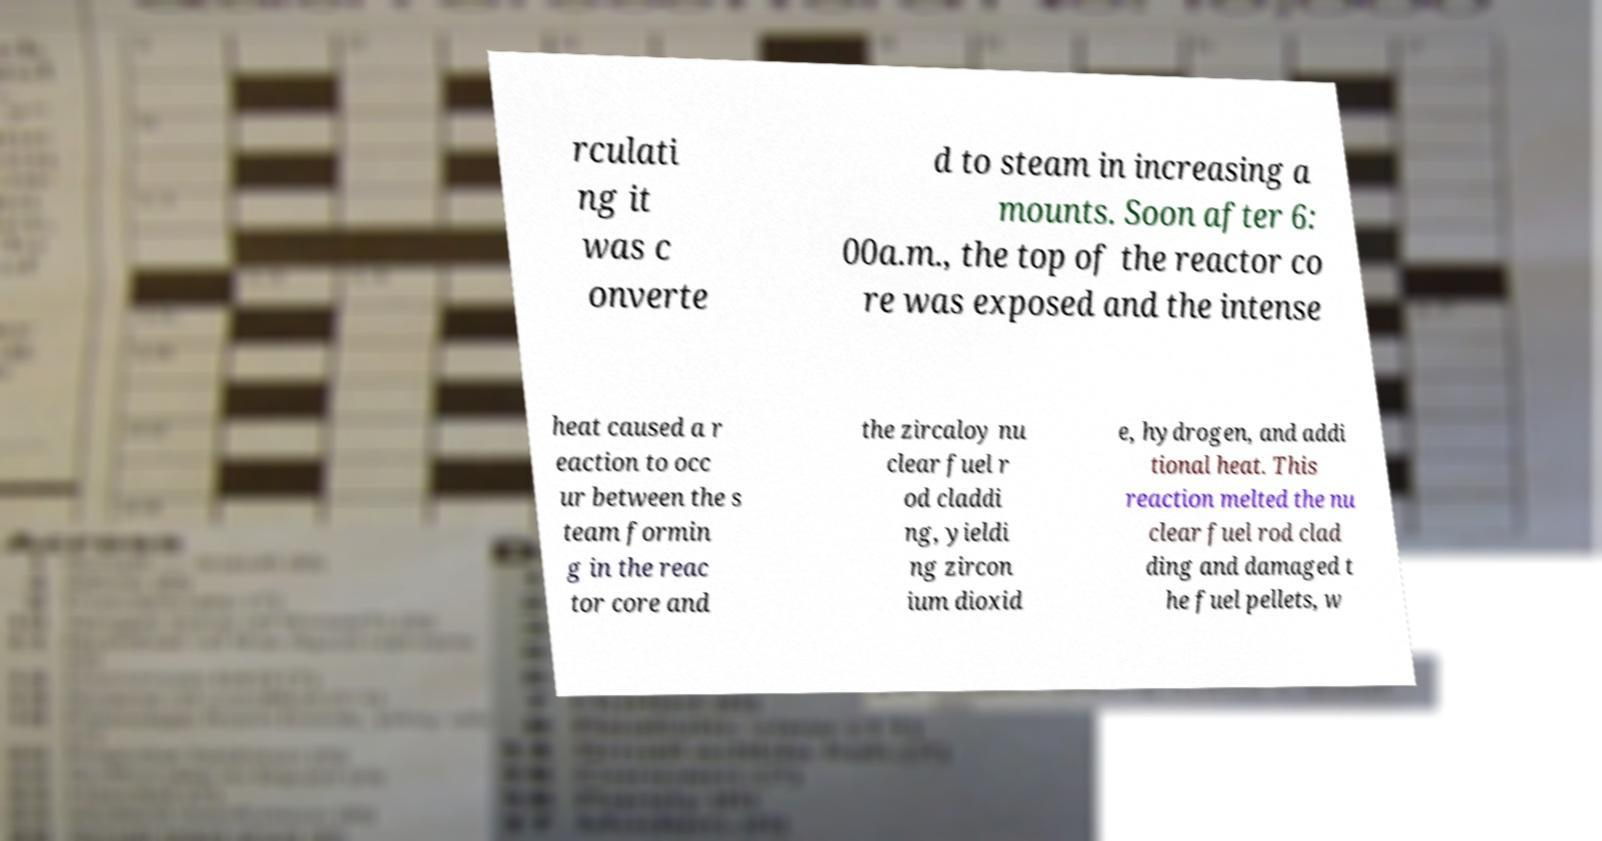Can you accurately transcribe the text from the provided image for me? rculati ng it was c onverte d to steam in increasing a mounts. Soon after 6: 00a.m., the top of the reactor co re was exposed and the intense heat caused a r eaction to occ ur between the s team formin g in the reac tor core and the zircaloy nu clear fuel r od claddi ng, yieldi ng zircon ium dioxid e, hydrogen, and addi tional heat. This reaction melted the nu clear fuel rod clad ding and damaged t he fuel pellets, w 